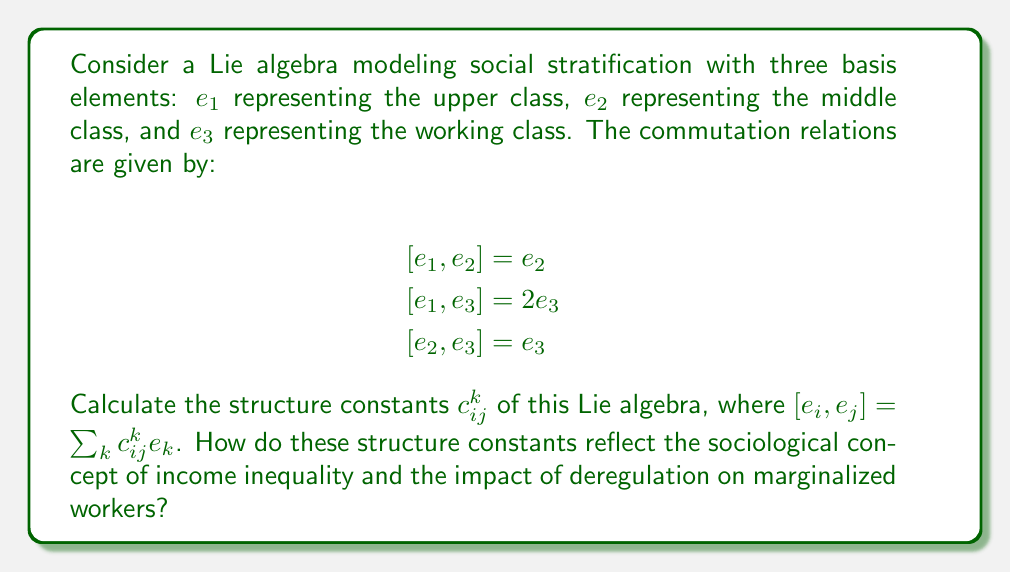Show me your answer to this math problem. To calculate the structure constants $c_{ij}^k$, we need to express each commutation relation in terms of the general form $[e_i, e_j] = \sum_k c_{ij}^k e_k$. 

1. For $[e_1, e_2] = e_2$:
   $c_{12}^1 = 0$, $c_{12}^2 = 1$, $c_{12}^3 = 0$

2. For $[e_1, e_3] = 2e_3$:
   $c_{13}^1 = 0$, $c_{13}^2 = 0$, $c_{13}^3 = 2$

3. For $[e_2, e_3] = e_3$:
   $c_{23}^1 = 0$, $c_{23}^2 = 0$, $c_{23}^3 = 1$

All other structure constants are zero due to the antisymmetry property of the Lie bracket: $c_{ji}^k = -c_{ij}^k$.

Interpretation in terms of social stratification:

1. $c_{12}^2 = 1$ suggests that the upper class ($e_1$) has a direct influence on the middle class ($e_2$), potentially through policies or economic decisions.

2. $c_{13}^3 = 2$ indicates a stronger influence of the upper class on the working class ($e_3$), which could represent the disproportionate impact of deregulation on marginalized workers.

3. $c_{23}^3 = 1$ shows that the middle class also affects the working class, but to a lesser extent than the upper class does.

The non-zero structure constants and their relative magnitudes reflect a hierarchical social structure where the upper class has the most significant influence on both the middle and working classes, potentially exacerbating income inequality through deregulation and other policies that disproportionately affect marginalized workers.
Answer: The non-zero structure constants are:

$c_{12}^2 = 1$
$c_{13}^3 = 2$
$c_{23}^3 = 1$

These constants reflect a hierarchical social structure with the upper class having the strongest influence on the working class, potentially exacerbating income inequality through deregulation and other policies that disproportionately affect marginalized workers. 